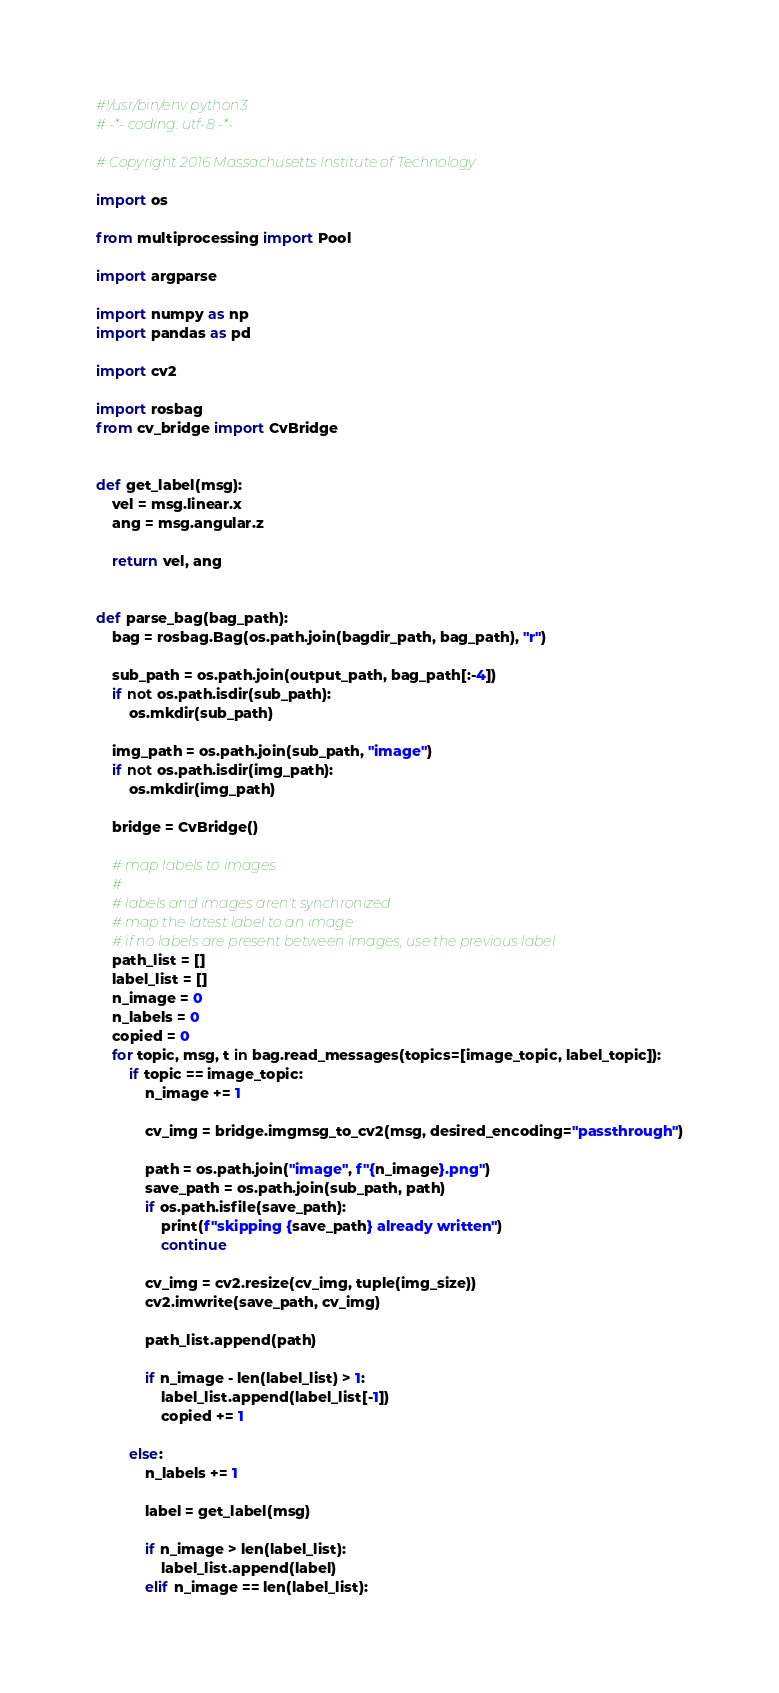<code> <loc_0><loc_0><loc_500><loc_500><_Python_>#!/usr/bin/env python3
# -*- coding: utf-8 -*-

# Copyright 2016 Massachusetts Institute of Technology

import os

from multiprocessing import Pool

import argparse

import numpy as np
import pandas as pd

import cv2

import rosbag
from cv_bridge import CvBridge


def get_label(msg):
    vel = msg.linear.x
    ang = msg.angular.z

    return vel, ang


def parse_bag(bag_path):
    bag = rosbag.Bag(os.path.join(bagdir_path, bag_path), "r")

    sub_path = os.path.join(output_path, bag_path[:-4])
    if not os.path.isdir(sub_path):
        os.mkdir(sub_path)

    img_path = os.path.join(sub_path, "image")
    if not os.path.isdir(img_path):
        os.mkdir(img_path)

    bridge = CvBridge()

    # map labels to images
    #
    # labels and images aren't synchronized
    # map the latest label to an image
    # if no labels are present between images, use the previous label
    path_list = []
    label_list = []
    n_image = 0
    n_labels = 0
    copied = 0
    for topic, msg, t in bag.read_messages(topics=[image_topic, label_topic]):
        if topic == image_topic:
            n_image += 1

            cv_img = bridge.imgmsg_to_cv2(msg, desired_encoding="passthrough")

            path = os.path.join("image", f"{n_image}.png")
            save_path = os.path.join(sub_path, path)
            if os.path.isfile(save_path):
                print(f"skipping {save_path} already written")
                continue

            cv_img = cv2.resize(cv_img, tuple(img_size))
            cv2.imwrite(save_path, cv_img)

            path_list.append(path)

            if n_image - len(label_list) > 1:
                label_list.append(label_list[-1])
                copied += 1

        else:
            n_labels += 1

            label = get_label(msg)

            if n_image > len(label_list):
                label_list.append(label)
            elif n_image == len(label_list):</code> 